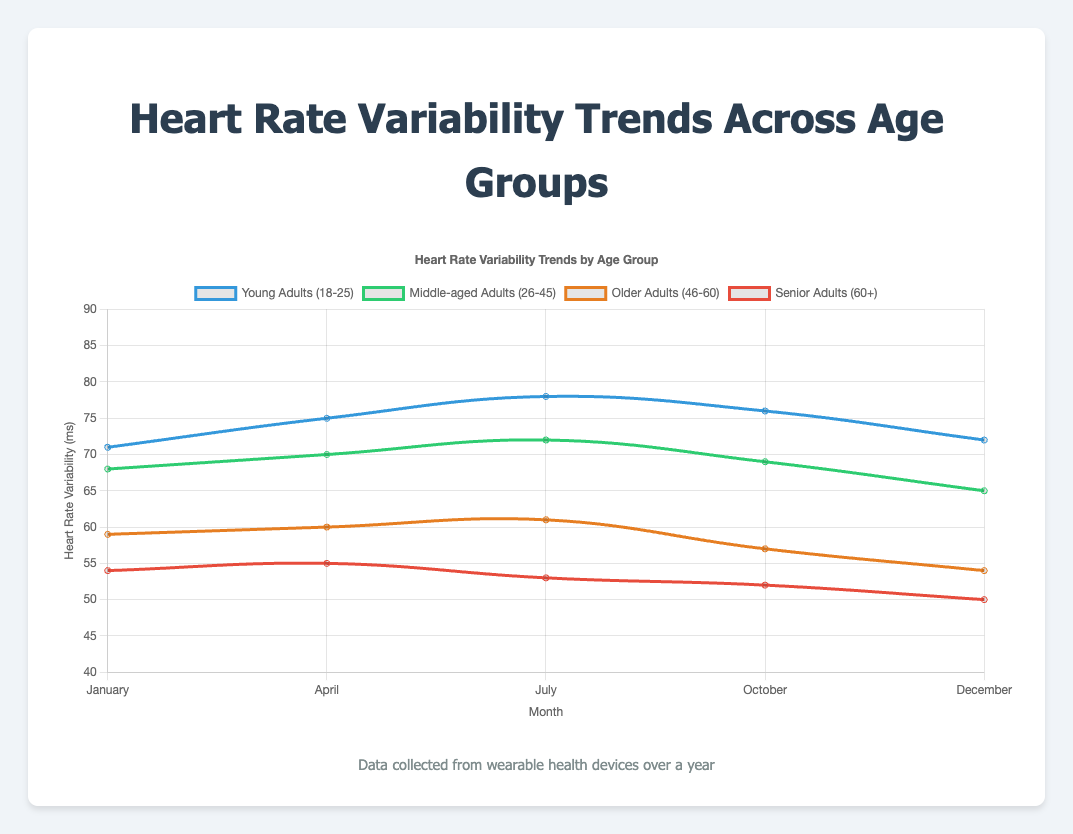Which group has the highest Heart Rate Variability (HRV) in July? To determine which group has the highest HRV in July, look at the HRV values for each demographic group during that month. The values are: Young Adults (78 ms), Middle-aged Adults (72 ms), Older Adults (61 ms), and Senior Adults (53 ms). The highest value is 78 ms for Young Adults.
Answer: Young Adults How does the HRV for Middle-aged Adults change from January to December? To observe the change in HRV for Middle-aged Adults, compare the HRV values for January (68 ms) and December (65 ms). Subtract the January value from the December value: 65 - 68 = -3 ms. This indicates a decrease of 3 ms.
Answer: Decreases by 3 ms Which group shows the largest increase in HRV from January to July? Check the HRV values for each group in January and July, compute the difference, and identify the largest increase: Young Adults (78 - 71 = 7 ms), Middle-aged Adults (72 - 68 = 4 ms), Older Adults (61 - 59 = 2 ms), Senior Adults (53 - 54 = -1 ms). The largest increase is 7 ms for Young Adults.
Answer: Young Adults What is the average HRV for Older Adults (46-60) over the months recorded? Calculate the average HRV for Older Adults by summing their values for January (59 ms), April (60 ms), July (61 ms), October (57 ms), and December (54 ms), then dividing by the number of months: (59 + 60 + 61 + 57 + 54) / 5 = 58.2 ms.
Answer: 58.2 ms Between which two months does the HRV for Senior Adults (60+) decline the most? Compare the HRV values of Senior Adults between consecutive months: January (54 ms), April (55 ms), July (53 ms), October (52 ms), December (50 ms). Calculate the declines and identify the largest: 55 - 53 = 2 ms (April to July), 53 - 52 = 1 ms (July to October), 52 - 50 = 2 ms (October to December). The largest decline (2 ms) occurs between April to July and October to December.
Answer: April to July and October to December In which month do all demographic groups have their highest recorded HRV? Review the HRV values for each group in each month and identify the month with the highest values for all groups: January (71, 68, 59, 54 ms), April (75, 70, 60, 55 ms), July (78, 72, 61, 53 ms), October (76, 69, 57, 52 ms), December (72, 65, 54, 50 ms). July has the highest HRV values.
Answer: July Which demographic group exhibits the most stable HRV across the year? Evaluate the stability of HRV by calculating the range (difference between maximum and minimum values) for each group: Young Adults (78 - 71 = 7 ms), Middle-aged Adults (72 - 65 = 7 ms), Older Adults (61 - 54 = 7 ms), Senior Adults (55 - 50 = 5 ms). The smallest range indicates the most stability, which is 5 ms for Senior Adults.
Answer: Senior Adults What is the total increase in HRV for Young Adults from January to October? Compute the HRV values for Young Adults in January (71 ms) and October (76 ms), then find the difference: 76 - 71 = 5 ms. This indicates a total increase of 5 ms.
Answer: 5 ms 